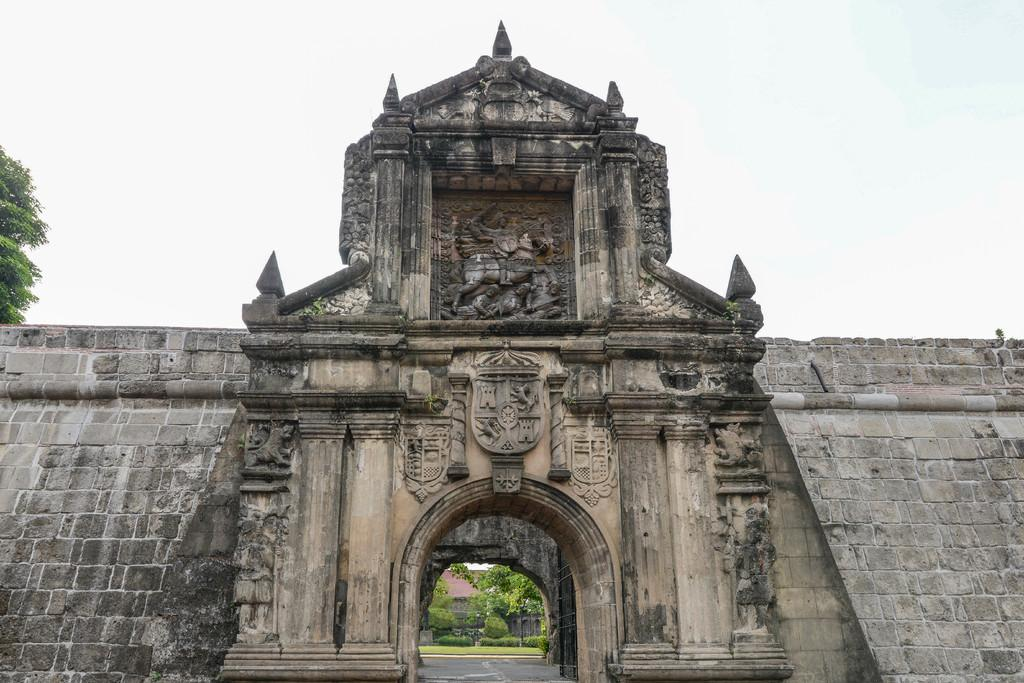What historical site is featured in the image? The image contains Fort Santiago. What type of vegetation can be seen in the image? There is a group of trees visible in the image. How would you describe the weather based on the image? The sky in the image appears cloudy. What type of pancake is being served at the restaurant in the image? There is no restaurant or pancake present in the image; it features Fort Santiago and a group of trees. What type of gold object can be seen in the image? There is no gold object present in the image. 